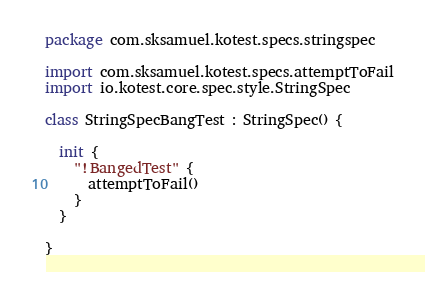Convert code to text. <code><loc_0><loc_0><loc_500><loc_500><_Kotlin_>package com.sksamuel.kotest.specs.stringspec

import com.sksamuel.kotest.specs.attemptToFail
import io.kotest.core.spec.style.StringSpec

class StringSpecBangTest : StringSpec() {

  init {
    "!BangedTest" {
      attemptToFail()
    }
  }

}
</code> 